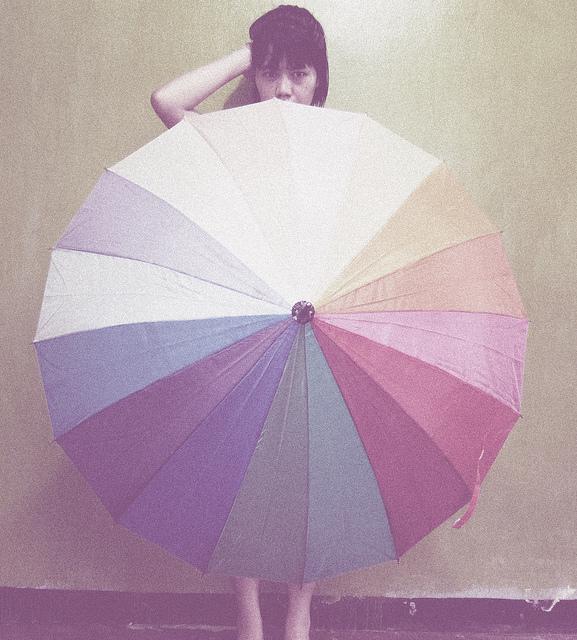How many dogs are running in the surf?
Give a very brief answer. 0. 